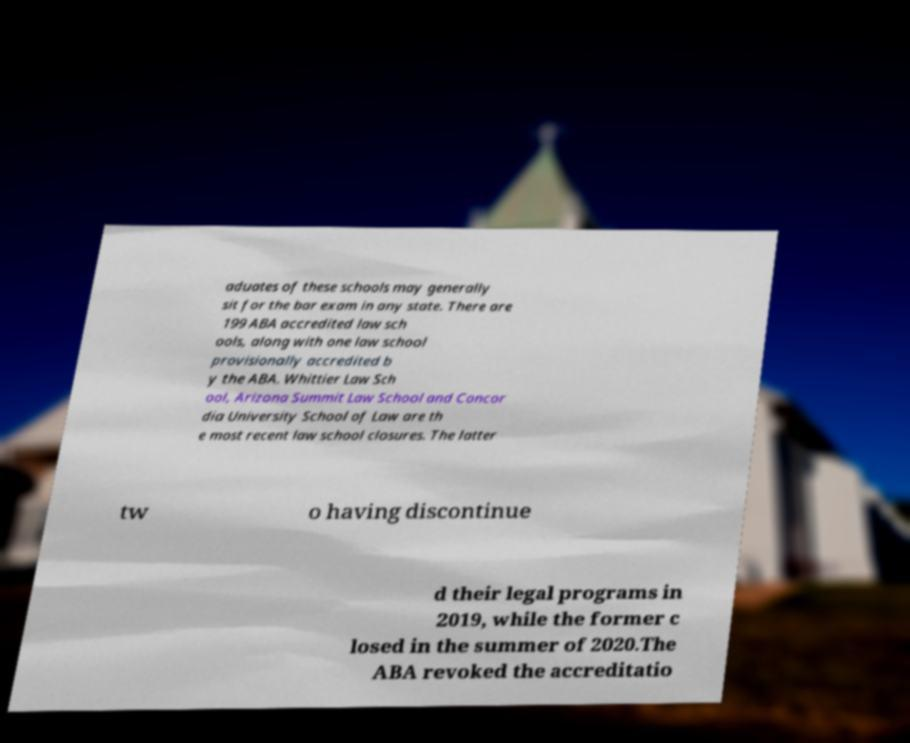Could you assist in decoding the text presented in this image and type it out clearly? aduates of these schools may generally sit for the bar exam in any state. There are 199 ABA accredited law sch ools, along with one law school provisionally accredited b y the ABA. Whittier Law Sch ool, Arizona Summit Law School and Concor dia University School of Law are th e most recent law school closures. The latter tw o having discontinue d their legal programs in 2019, while the former c losed in the summer of 2020.The ABA revoked the accreditatio 